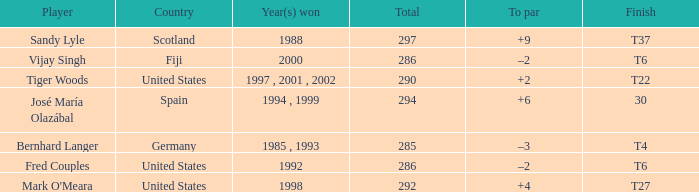Which player has +2 to par? Tiger Woods. 